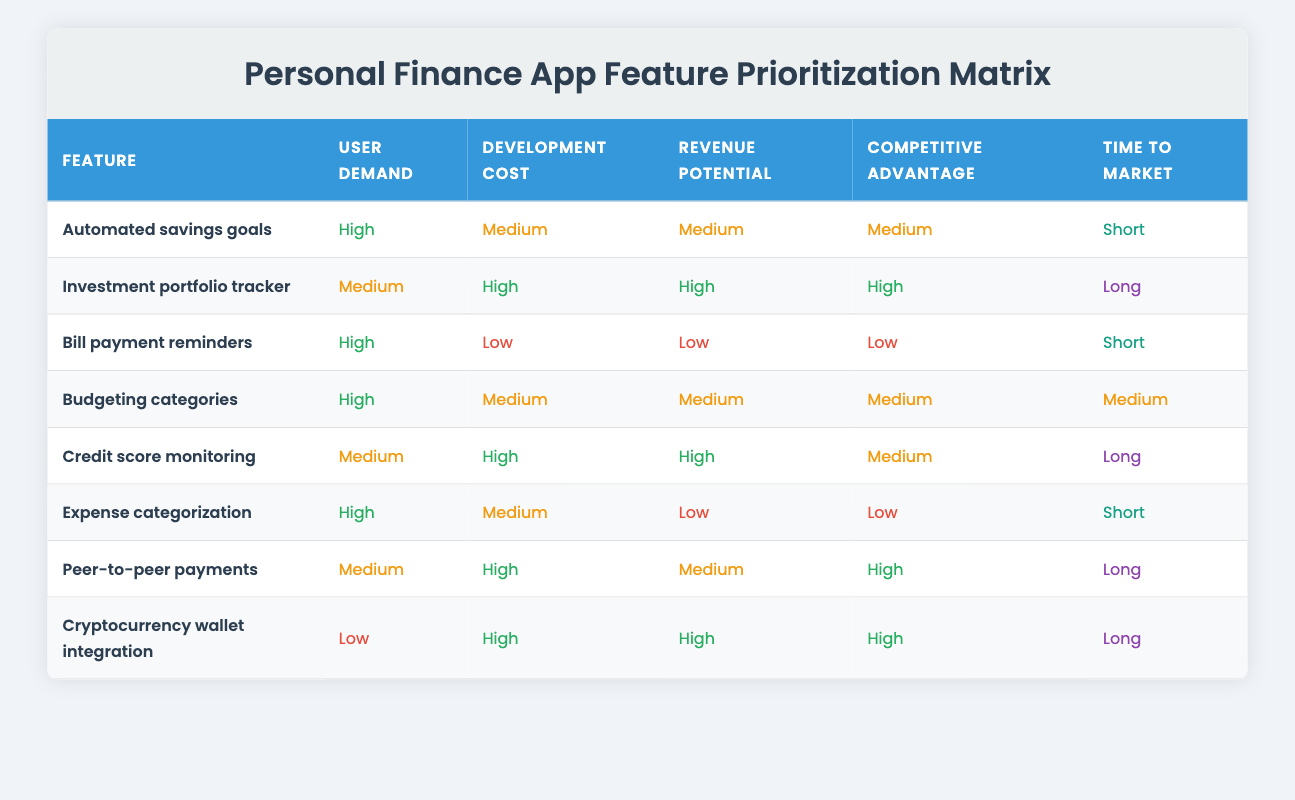What feature has the highest user demand? By checking the "User demand" column in the table, "Automated savings goals," "Bill payment reminders," "Budgeting categories," and "Expense categorization" all have a "High" value. However, since the question only seeks one feature, I’ll choose the first one listed: "Automated savings goals."
Answer: Automated savings goals Which feature has the lowest revenue potential? The "Revenue potential" column shows the values for each feature. The values listed are Low, Medium, and High, and "Bill payment reminders" and "Expense categorization" both have a "Low" value. However, "Bill payment reminders" is the first one listed among those, making it the answer.
Answer: Bill payment reminders Which feature takes the least time to market? I need to look at the "Time to market" column. The values categorized as "Short" apply to "Automated savings goals," "Bill payment reminders," and "Expense categorization." Since "Automated savings goals" is mentioned first in the table, it takes the least time to market.
Answer: Automated savings goals How many features have a medium development cost? To find this, I analyze the "Development cost" column for the count of features marked as "Medium." The features that have a "Medium" cost are "Automated savings goals," "Budgeting categories," and "Expense categorization." Thus, there are three features with this cost classification.
Answer: 3 Is there any feature with high user demand that also has low revenue potential? Looking closely, the features with "High" user demand include "Automated savings goals," "Bill payment reminders," "Budgeting categories," and "Expense categorization." Checking their revenue potential, "Bill payment reminders" has "Low" revenue potential. Hence, the answer is yes, there is one feature that meets both criteria.
Answer: Yes If we consider only features with medium development cost, what revenue potential is most common amongst them? First, I check for features with a "Medium" development cost, which are "Automated savings goals," "Budgeting categories," and "Expense categorization." Next, reviewing their revenue potentials gives me Medium, Medium, and Low. The most common is "Medium," shared by two of the three features.
Answer: Medium What is the feature with the highest competitive advantage that also has high user demand? The "User demand" column has features with "High" user demand: "Automated savings goals," "Bill payment reminders," "Budgeting categories," and "Expense categorization." I then compare this to the "Competitive advantage" column. "Automated savings goals," "Budgeting categories," and "Bill payment reminders" all score "Medium," but none have a high competitive advantage. None of the features with high user demand list a “High” competitive advantage, leading to the conclusion there are none.
Answer: None How many features require a long time to market? I go through the "Time to market" column, noting the features classified as “Long.” They are "Investment portfolio tracker," "Credit score monitoring," "Peer-to-peer payments," and "Cryptocurrency wallet integration." In total, there are four features requiring a long time to market.
Answer: 4 